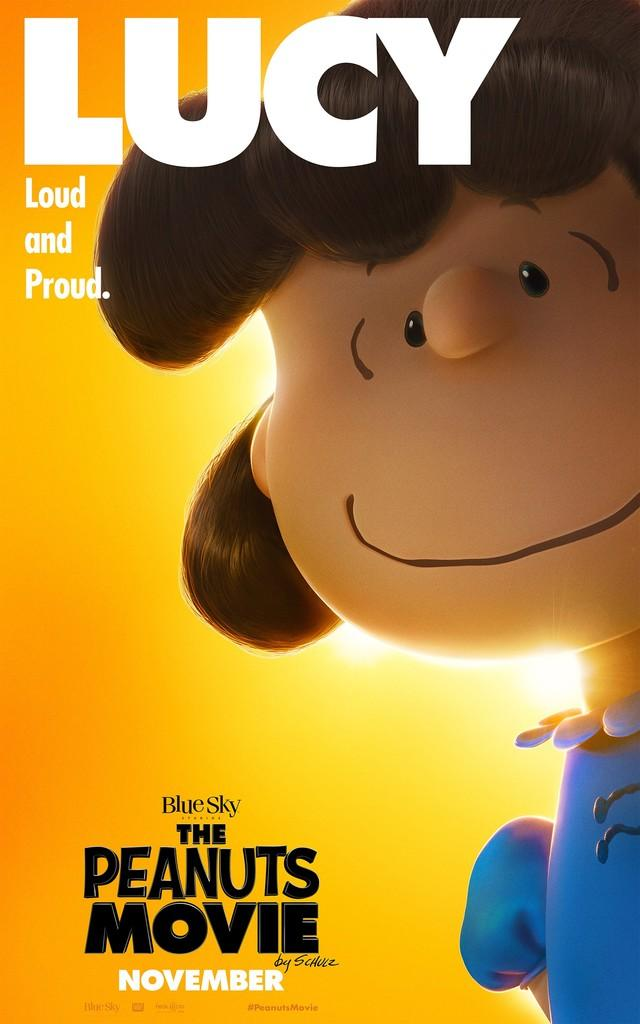Provide a one-sentence caption for the provided image. A movie poster for The Peanuts Movie advertising it is released in November. 